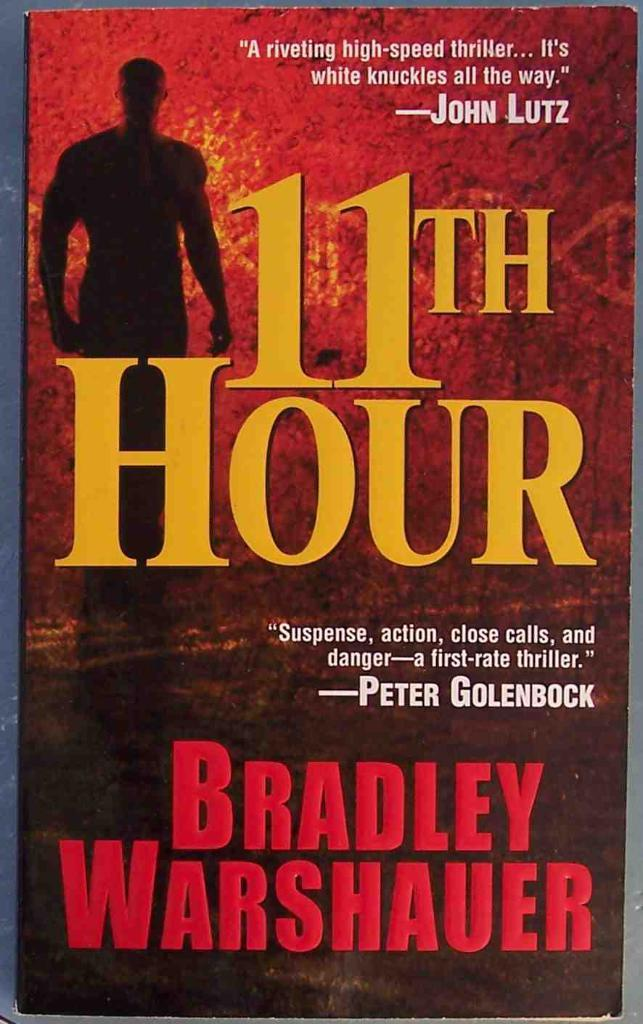<image>
Give a short and clear explanation of the subsequent image. The front cover of a book called 11th Hour, written by Bradley Warshauer. 